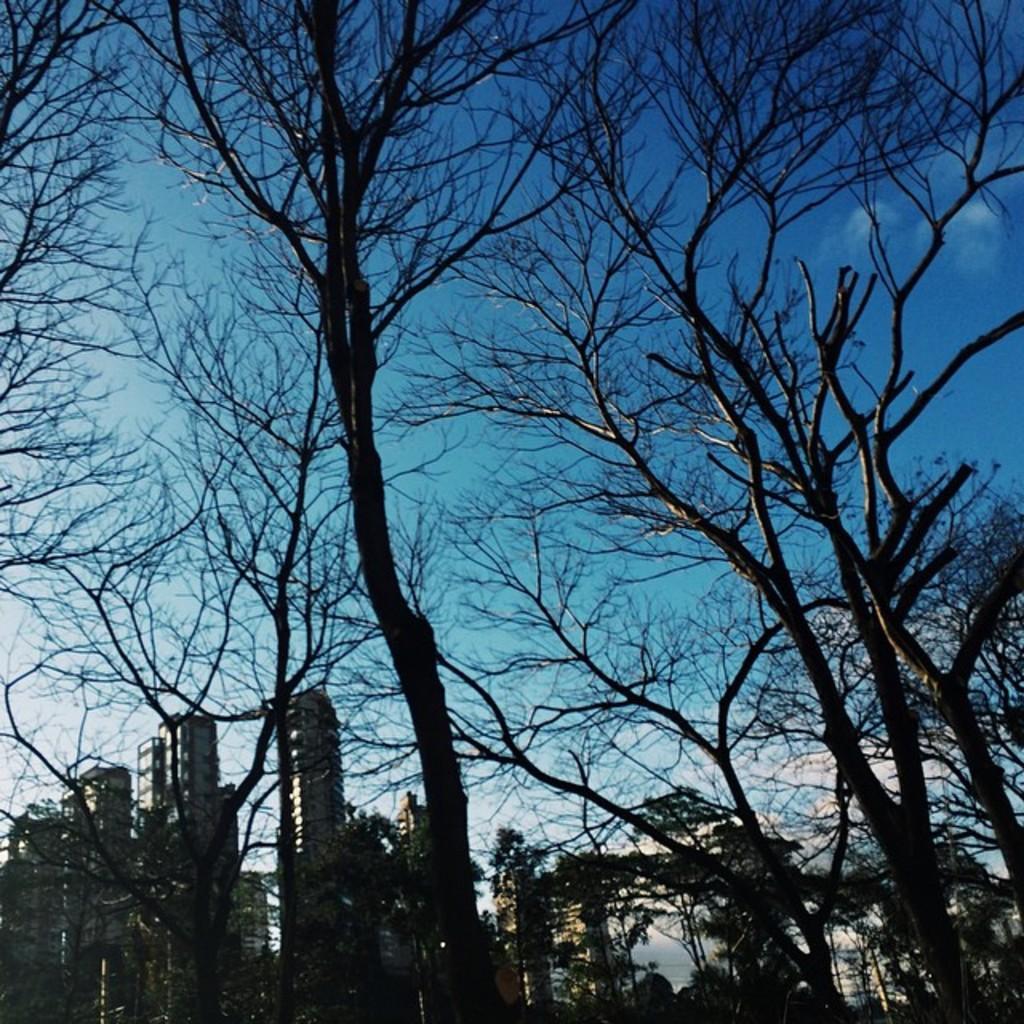How would you summarize this image in a sentence or two? In this image I can see the dark picture in which I can see few trees and few buildings. In the background I can see the sky. 